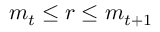Convert formula to latex. <formula><loc_0><loc_0><loc_500><loc_500>m _ { t } \leq r \leq m _ { t + 1 }</formula> 